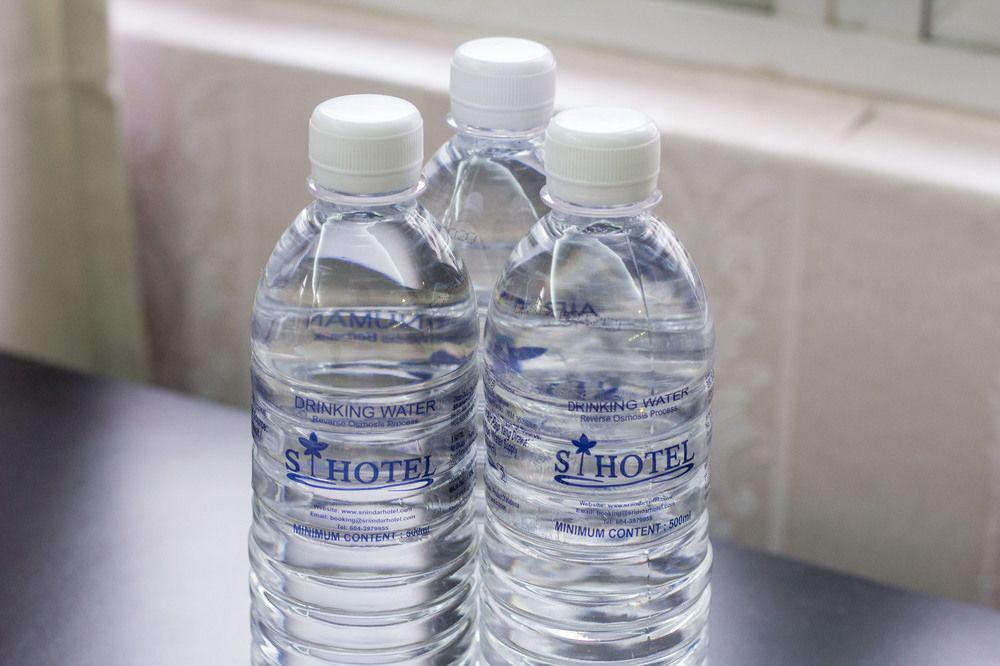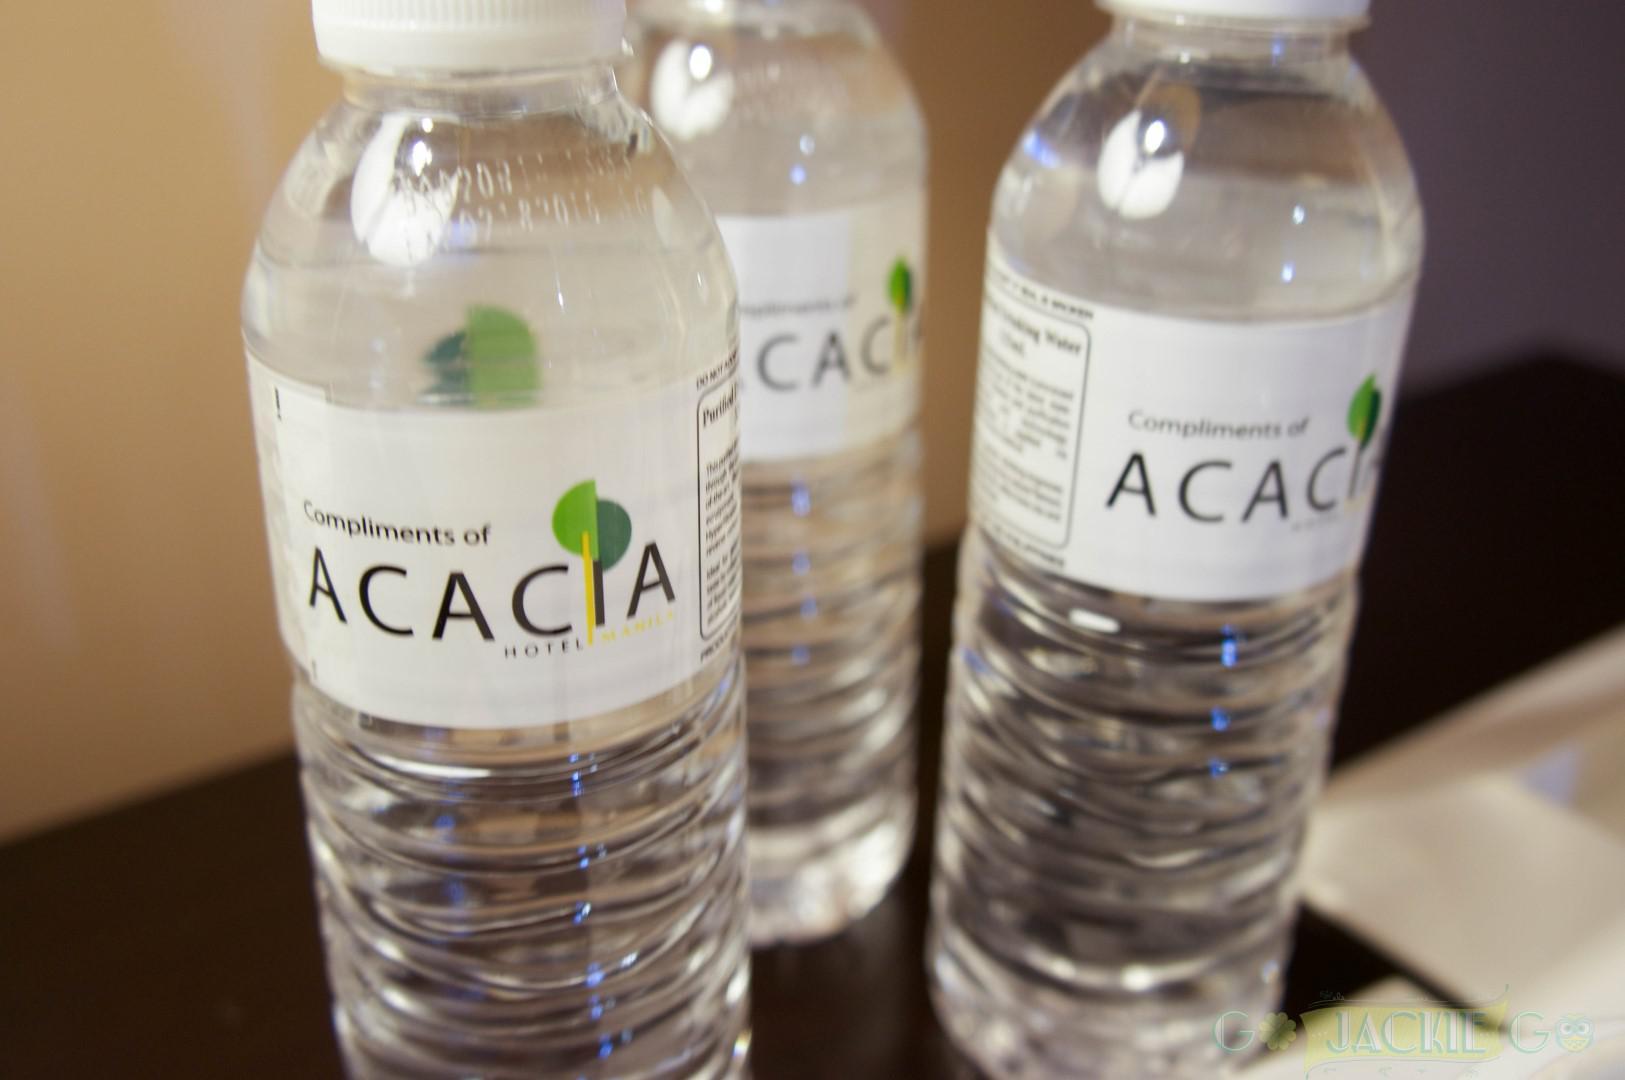The first image is the image on the left, the second image is the image on the right. Considering the images on both sides, is "The left and right image contains the same number of containers filled with water." valid? Answer yes or no. Yes. The first image is the image on the left, the second image is the image on the right. Analyze the images presented: Is the assertion "The right and left images include the same number of water containers." valid? Answer yes or no. Yes. 